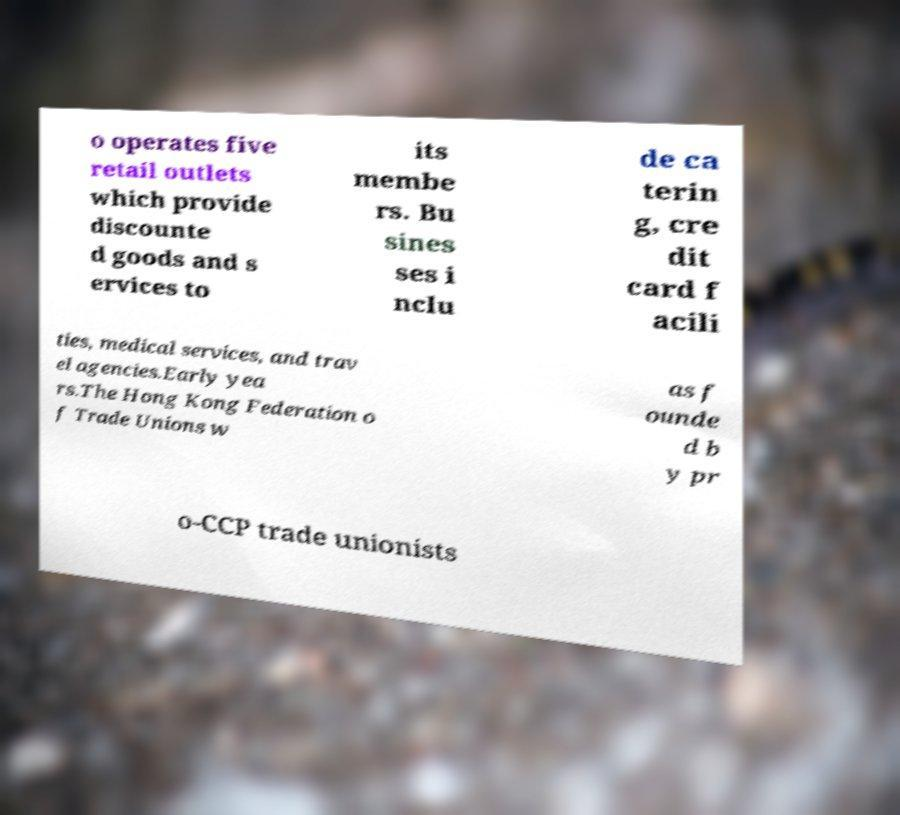I need the written content from this picture converted into text. Can you do that? o operates five retail outlets which provide discounte d goods and s ervices to its membe rs. Bu sines ses i nclu de ca terin g, cre dit card f acili ties, medical services, and trav el agencies.Early yea rs.The Hong Kong Federation o f Trade Unions w as f ounde d b y pr o-CCP trade unionists 